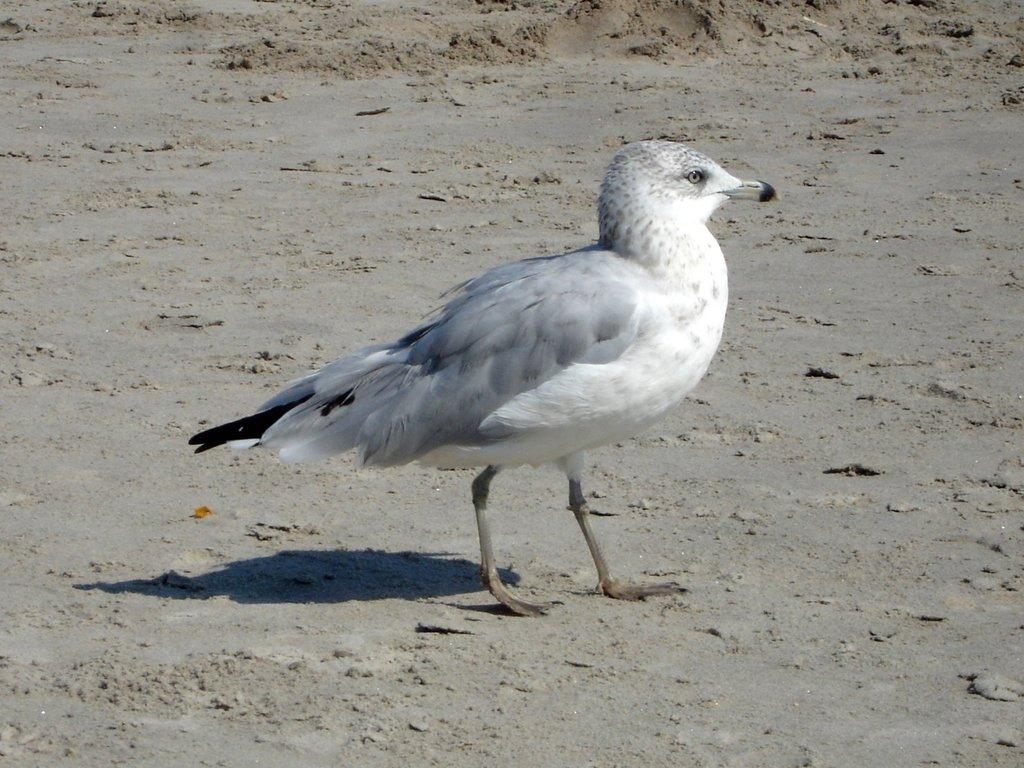What type of animal can be seen in the image? There is a bird in the image. Where is the bird located in the image? The bird is on the ground. What territory does the bird claim as its own in the image? There is no indication of the bird claiming any territory in the image. 